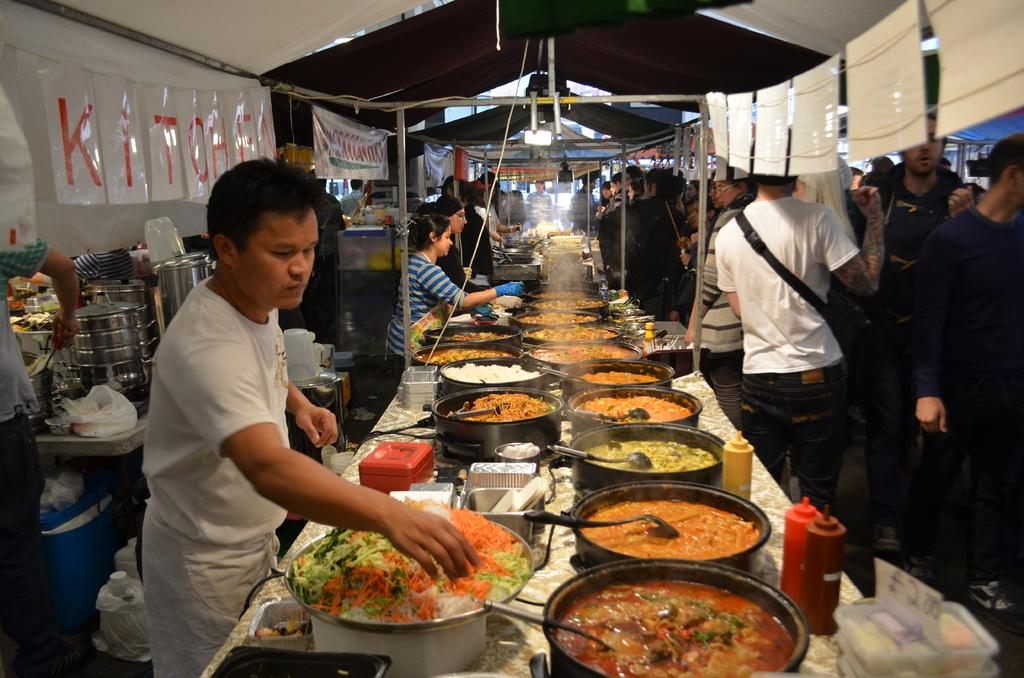What type of furniture is in the image? There is a table in the image. What is on the table? Dishes are present on the table. What activity is taking place in the image? People are cooking food in the image. What part of a building can be seen in the image? There is a roof visible in the image. How many jellyfish are swimming in the pot of boiling water in the image? There are no jellyfish present in the image; people are cooking food in a pot. What type of expert is providing cooking advice in the image? There is no expert present in the image; people are cooking food without any visible assistance. 